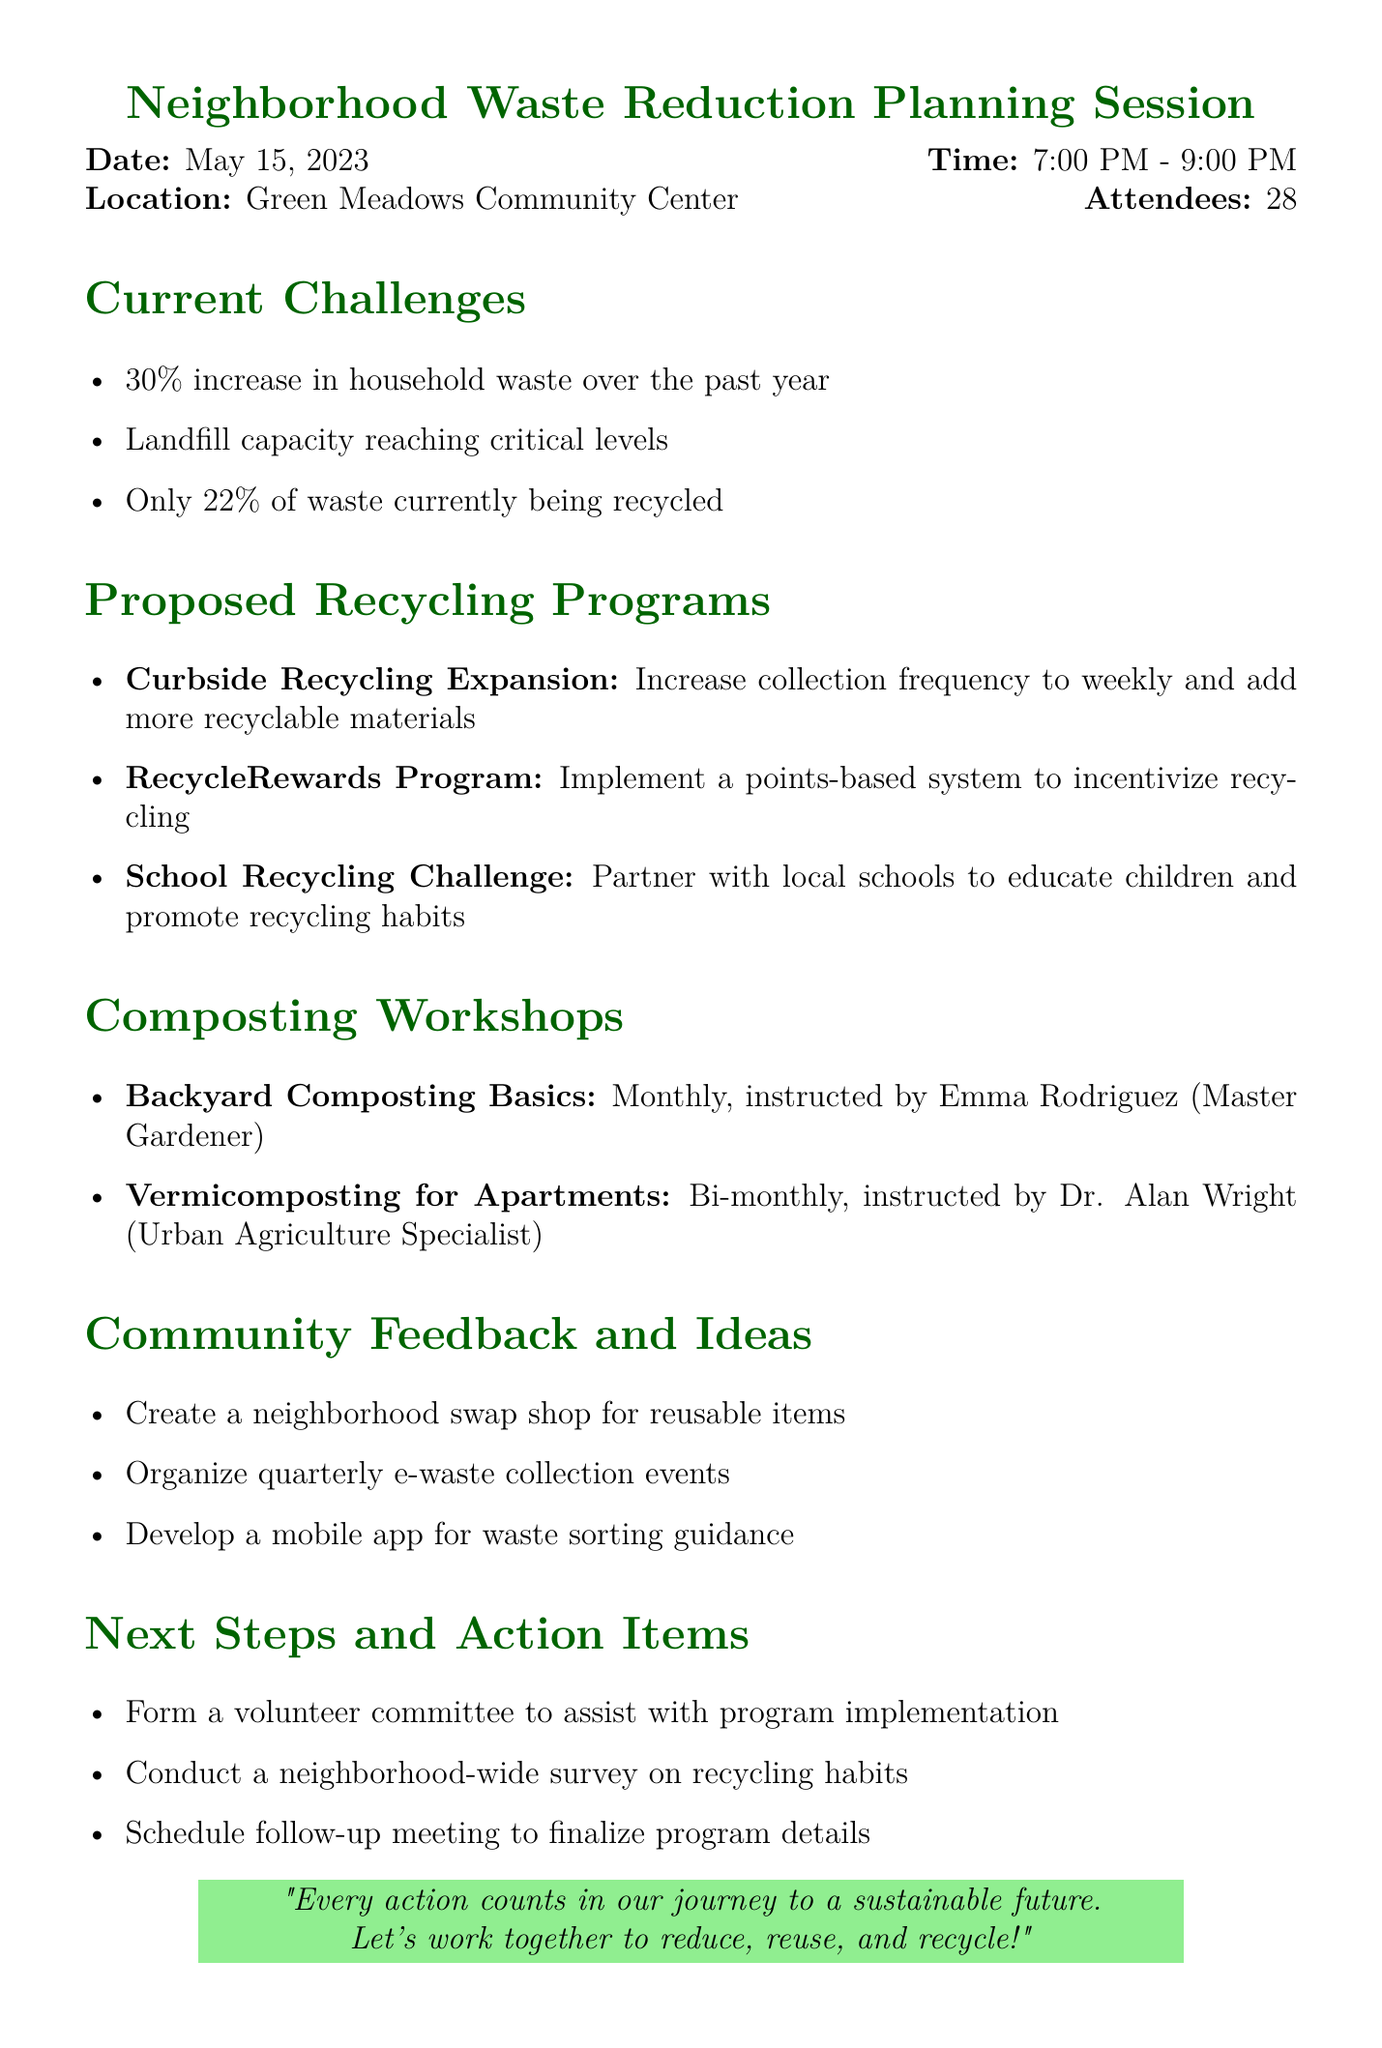What date was the meeting held? The document states that the meeting took place on May 15, 2023.
Answer: May 15, 2023 How many attendees were present at the meeting? The document mentions that there were 28 attendees.
Answer: 28 Who is the instructor for the "Backyard Composting Basics" workshop? According to the document, the instructor for this workshop is Emma Rodriguez.
Answer: Emma Rodriguez What is the proposed frequency for the "Vermicomposting for Apartments" workshop? The document states that this workshop is proposed to be held bi-monthly.
Answer: Bi-monthly What percentage of waste is currently being recycled? The document indicates that only 22% of waste is currently being recycled.
Answer: 22% What is one key suggestion from the community feedback? The document lists several suggestions, one of which is creating a neighborhood swap shop for reusable items.
Answer: Create a neighborhood swap shop for reusable items What is the name of the program designed to incentivize recycling? The document describes the "RecycleRewards Program" as a program to incentivize recycling.
Answer: RecycleRewards Program What action item involves a survey? The document states that an action item is to conduct a neighborhood-wide survey on recycling habits.
Answer: Conduct a neighborhood-wide survey on recycling habits Who presented the current waste management challenges? The document mentions that Michael Chen from the City Waste Management Department presented this topic.
Answer: Michael Chen 